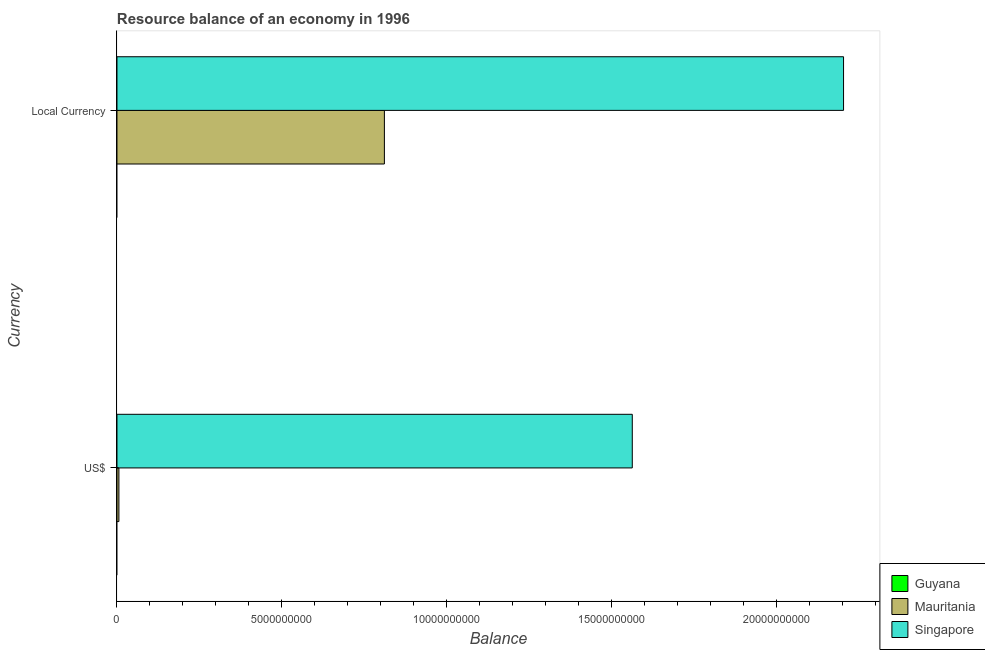How many bars are there on the 1st tick from the top?
Make the answer very short. 2. What is the label of the 2nd group of bars from the top?
Your response must be concise. US$. What is the resource balance in us$ in Mauritania?
Make the answer very short. 5.91e+07. Across all countries, what is the maximum resource balance in constant us$?
Provide a succinct answer. 2.20e+1. In which country was the resource balance in constant us$ maximum?
Provide a succinct answer. Singapore. What is the total resource balance in us$ in the graph?
Your response must be concise. 1.57e+1. What is the difference between the resource balance in constant us$ in Singapore and that in Mauritania?
Make the answer very short. 1.39e+1. What is the difference between the resource balance in us$ in Singapore and the resource balance in constant us$ in Guyana?
Make the answer very short. 1.56e+1. What is the average resource balance in us$ per country?
Ensure brevity in your answer.  5.23e+09. What is the difference between the resource balance in constant us$ and resource balance in us$ in Singapore?
Provide a succinct answer. 6.41e+09. In how many countries, is the resource balance in us$ greater than 20000000000 units?
Your answer should be compact. 0. What is the ratio of the resource balance in constant us$ in Singapore to that in Mauritania?
Your answer should be very brief. 2.72. In how many countries, is the resource balance in constant us$ greater than the average resource balance in constant us$ taken over all countries?
Keep it short and to the point. 1. What is the difference between two consecutive major ticks on the X-axis?
Offer a terse response. 5.00e+09. Are the values on the major ticks of X-axis written in scientific E-notation?
Give a very brief answer. No. Does the graph contain grids?
Provide a succinct answer. No. How many legend labels are there?
Keep it short and to the point. 3. How are the legend labels stacked?
Keep it short and to the point. Vertical. What is the title of the graph?
Your answer should be very brief. Resource balance of an economy in 1996. What is the label or title of the X-axis?
Provide a succinct answer. Balance. What is the label or title of the Y-axis?
Offer a very short reply. Currency. What is the Balance in Mauritania in US$?
Your response must be concise. 5.91e+07. What is the Balance in Singapore in US$?
Offer a terse response. 1.56e+1. What is the Balance in Mauritania in Local Currency?
Keep it short and to the point. 8.11e+09. What is the Balance of Singapore in Local Currency?
Provide a short and direct response. 2.20e+1. Across all Currency, what is the maximum Balance in Mauritania?
Provide a short and direct response. 8.11e+09. Across all Currency, what is the maximum Balance of Singapore?
Provide a short and direct response. 2.20e+1. Across all Currency, what is the minimum Balance in Mauritania?
Ensure brevity in your answer.  5.91e+07. Across all Currency, what is the minimum Balance in Singapore?
Give a very brief answer. 1.56e+1. What is the total Balance in Mauritania in the graph?
Make the answer very short. 8.17e+09. What is the total Balance of Singapore in the graph?
Ensure brevity in your answer.  3.77e+1. What is the difference between the Balance of Mauritania in US$ and that in Local Currency?
Offer a very short reply. -8.05e+09. What is the difference between the Balance of Singapore in US$ and that in Local Currency?
Offer a very short reply. -6.41e+09. What is the difference between the Balance in Mauritania in US$ and the Balance in Singapore in Local Currency?
Make the answer very short. -2.20e+1. What is the average Balance of Mauritania per Currency?
Provide a succinct answer. 4.08e+09. What is the average Balance in Singapore per Currency?
Your answer should be compact. 1.88e+1. What is the difference between the Balance in Mauritania and Balance in Singapore in US$?
Offer a terse response. -1.56e+1. What is the difference between the Balance in Mauritania and Balance in Singapore in Local Currency?
Make the answer very short. -1.39e+1. What is the ratio of the Balance in Mauritania in US$ to that in Local Currency?
Give a very brief answer. 0.01. What is the ratio of the Balance in Singapore in US$ to that in Local Currency?
Provide a short and direct response. 0.71. What is the difference between the highest and the second highest Balance in Mauritania?
Keep it short and to the point. 8.05e+09. What is the difference between the highest and the second highest Balance in Singapore?
Provide a short and direct response. 6.41e+09. What is the difference between the highest and the lowest Balance in Mauritania?
Give a very brief answer. 8.05e+09. What is the difference between the highest and the lowest Balance in Singapore?
Offer a terse response. 6.41e+09. 